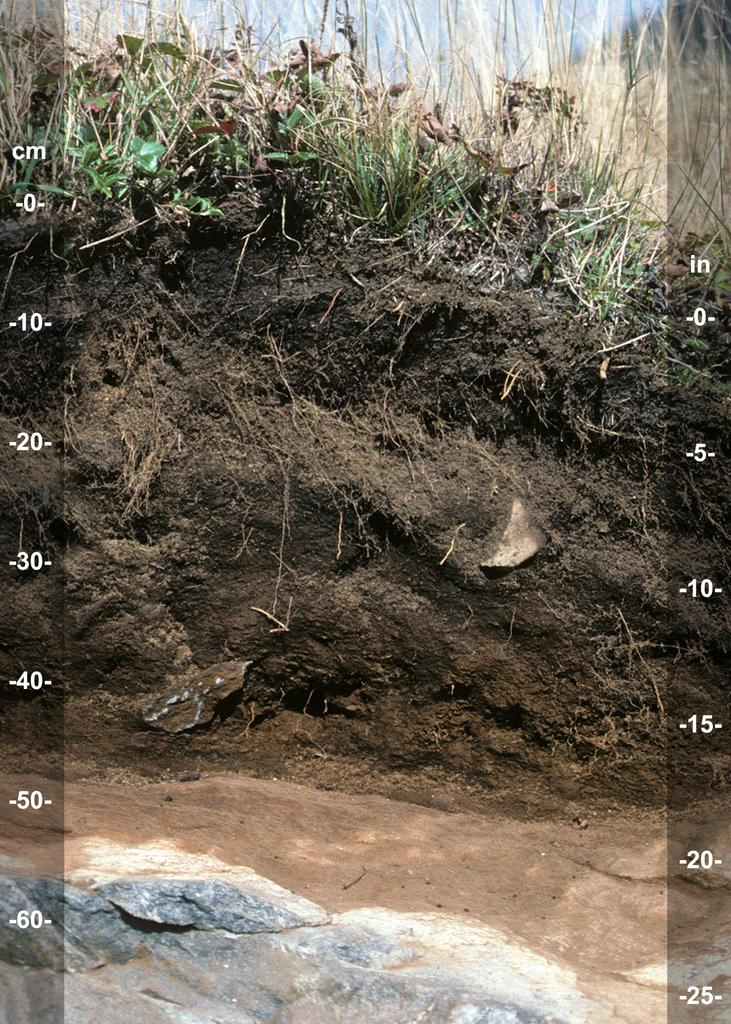What is the main substance visible in the image? There is mud in the image. What is growing on the mud? There are plants on the mud. What additional elements are present on the image? There are numbers and alphabets on both sides of the image, and a stone at the bottom of the image. What type of metal can be seen bursting through the mud in the image? There is no metal present in the image, nor is there any indication of something bursting through the mud. 